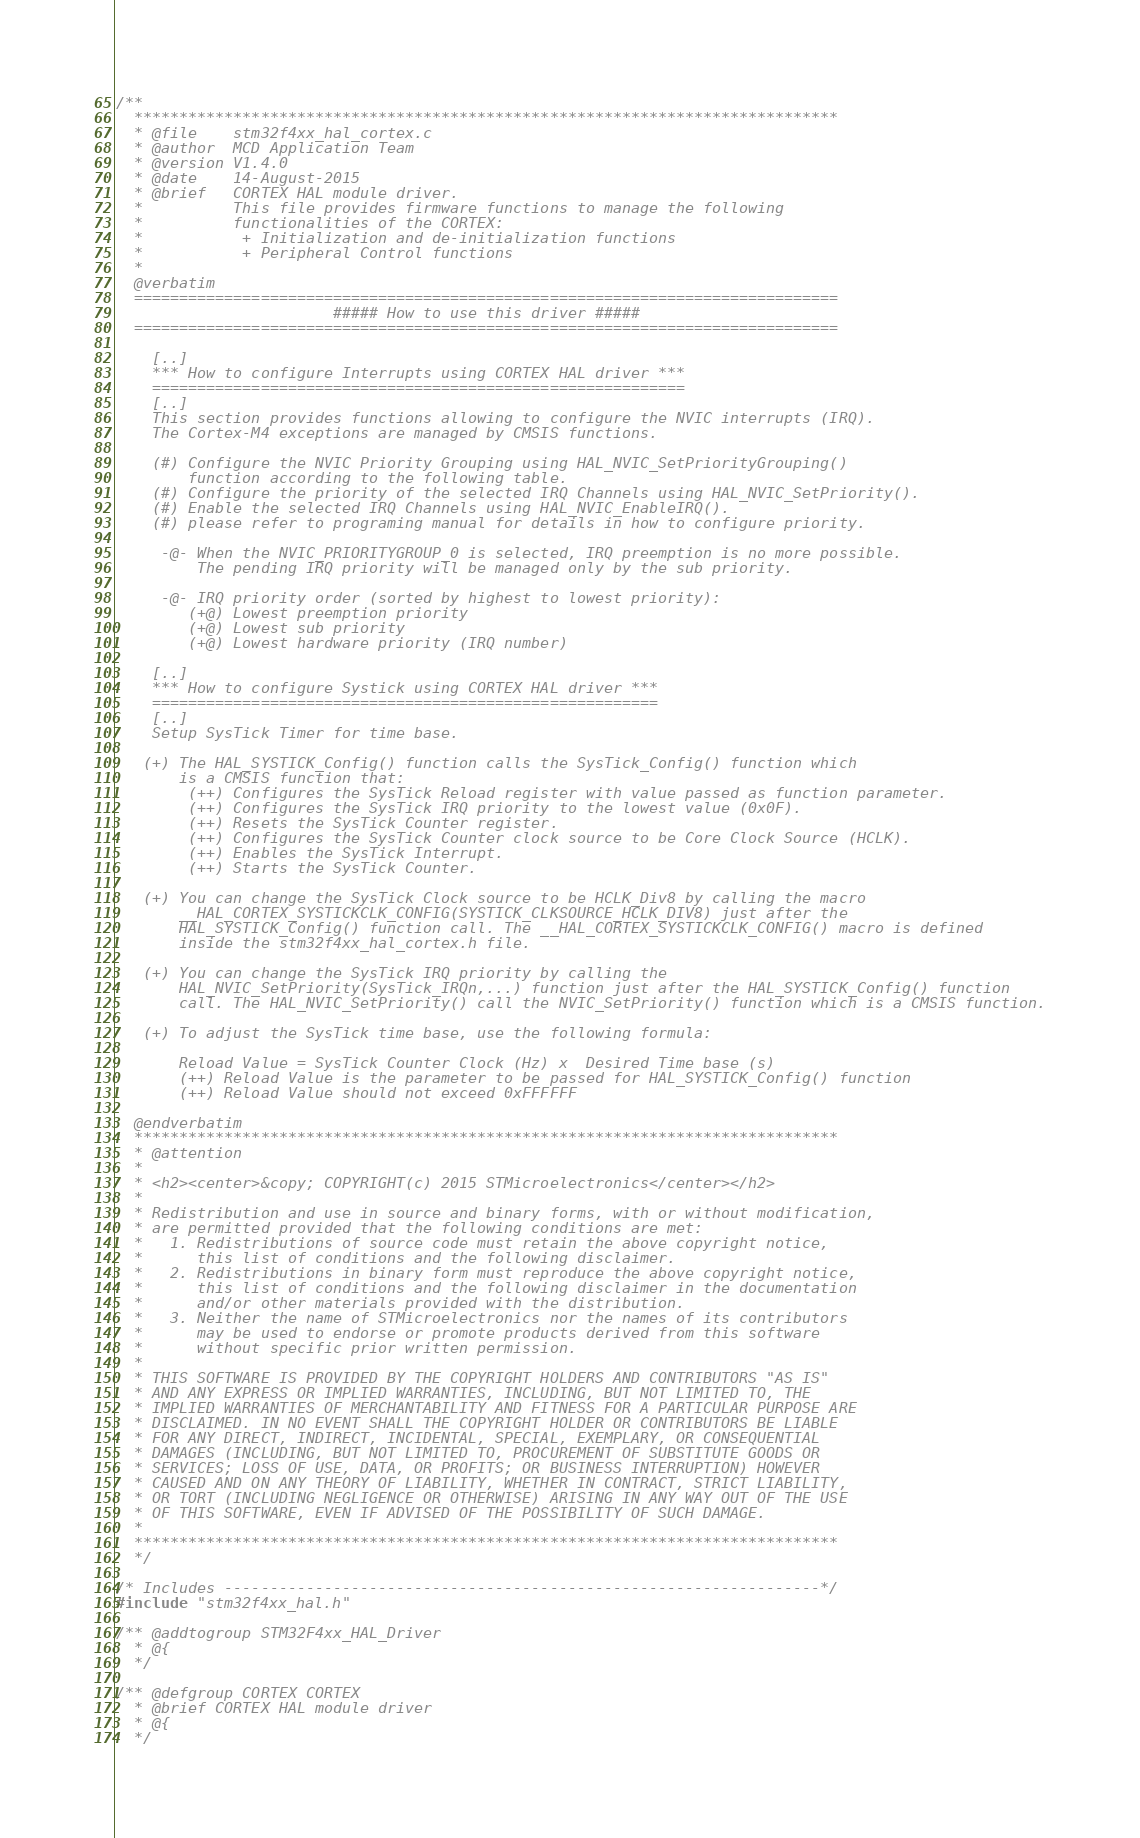<code> <loc_0><loc_0><loc_500><loc_500><_C_>/**
  ******************************************************************************
  * @file    stm32f4xx_hal_cortex.c
  * @author  MCD Application Team
  * @version V1.4.0
  * @date    14-August-2015
  * @brief   CORTEX HAL module driver.
  *          This file provides firmware functions to manage the following 
  *          functionalities of the CORTEX:
  *           + Initialization and de-initialization functions
  *           + Peripheral Control functions 
  *
  @verbatim  
  ==============================================================================
                        ##### How to use this driver #####
  ==============================================================================

    [..]  
    *** How to configure Interrupts using CORTEX HAL driver ***
    ===========================================================
    [..]     
    This section provides functions allowing to configure the NVIC interrupts (IRQ).
    The Cortex-M4 exceptions are managed by CMSIS functions.
   
    (#) Configure the NVIC Priority Grouping using HAL_NVIC_SetPriorityGrouping()
        function according to the following table.
    (#) Configure the priority of the selected IRQ Channels using HAL_NVIC_SetPriority(). 
    (#) Enable the selected IRQ Channels using HAL_NVIC_EnableIRQ().
    (#) please refer to programing manual for details in how to configure priority. 
      
     -@- When the NVIC_PRIORITYGROUP_0 is selected, IRQ preemption is no more possible. 
         The pending IRQ priority will be managed only by the sub priority.
   
     -@- IRQ priority order (sorted by highest to lowest priority):
        (+@) Lowest preemption priority
        (+@) Lowest sub priority
        (+@) Lowest hardware priority (IRQ number)
 
    [..]  
    *** How to configure Systick using CORTEX HAL driver ***
    ========================================================
    [..]
    Setup SysTick Timer for time base.
           
   (+) The HAL_SYSTICK_Config() function calls the SysTick_Config() function which
       is a CMSIS function that:
        (++) Configures the SysTick Reload register with value passed as function parameter.
        (++) Configures the SysTick IRQ priority to the lowest value (0x0F).
        (++) Resets the SysTick Counter register.
        (++) Configures the SysTick Counter clock source to be Core Clock Source (HCLK).
        (++) Enables the SysTick Interrupt.
        (++) Starts the SysTick Counter.
    
   (+) You can change the SysTick Clock source to be HCLK_Div8 by calling the macro
       __HAL_CORTEX_SYSTICKCLK_CONFIG(SYSTICK_CLKSOURCE_HCLK_DIV8) just after the
       HAL_SYSTICK_Config() function call. The __HAL_CORTEX_SYSTICKCLK_CONFIG() macro is defined
       inside the stm32f4xx_hal_cortex.h file.

   (+) You can change the SysTick IRQ priority by calling the
       HAL_NVIC_SetPriority(SysTick_IRQn,...) function just after the HAL_SYSTICK_Config() function 
       call. The HAL_NVIC_SetPriority() call the NVIC_SetPriority() function which is a CMSIS function.

   (+) To adjust the SysTick time base, use the following formula:
                            
       Reload Value = SysTick Counter Clock (Hz) x  Desired Time base (s)
       (++) Reload Value is the parameter to be passed for HAL_SYSTICK_Config() function
       (++) Reload Value should not exceed 0xFFFFFF
   
  @endverbatim
  ******************************************************************************
  * @attention
  *
  * <h2><center>&copy; COPYRIGHT(c) 2015 STMicroelectronics</center></h2>
  *
  * Redistribution and use in source and binary forms, with or without modification,
  * are permitted provided that the following conditions are met:
  *   1. Redistributions of source code must retain the above copyright notice,
  *      this list of conditions and the following disclaimer.
  *   2. Redistributions in binary form must reproduce the above copyright notice,
  *      this list of conditions and the following disclaimer in the documentation
  *      and/or other materials provided with the distribution.
  *   3. Neither the name of STMicroelectronics nor the names of its contributors
  *      may be used to endorse or promote products derived from this software
  *      without specific prior written permission.
  *
  * THIS SOFTWARE IS PROVIDED BY THE COPYRIGHT HOLDERS AND CONTRIBUTORS "AS IS"
  * AND ANY EXPRESS OR IMPLIED WARRANTIES, INCLUDING, BUT NOT LIMITED TO, THE
  * IMPLIED WARRANTIES OF MERCHANTABILITY AND FITNESS FOR A PARTICULAR PURPOSE ARE
  * DISCLAIMED. IN NO EVENT SHALL THE COPYRIGHT HOLDER OR CONTRIBUTORS BE LIABLE
  * FOR ANY DIRECT, INDIRECT, INCIDENTAL, SPECIAL, EXEMPLARY, OR CONSEQUENTIAL
  * DAMAGES (INCLUDING, BUT NOT LIMITED TO, PROCUREMENT OF SUBSTITUTE GOODS OR
  * SERVICES; LOSS OF USE, DATA, OR PROFITS; OR BUSINESS INTERRUPTION) HOWEVER
  * CAUSED AND ON ANY THEORY OF LIABILITY, WHETHER IN CONTRACT, STRICT LIABILITY,
  * OR TORT (INCLUDING NEGLIGENCE OR OTHERWISE) ARISING IN ANY WAY OUT OF THE USE
  * OF THIS SOFTWARE, EVEN IF ADVISED OF THE POSSIBILITY OF SUCH DAMAGE.
  *
  ******************************************************************************
  */

/* Includes ------------------------------------------------------------------*/
#include "stm32f4xx_hal.h"

/** @addtogroup STM32F4xx_HAL_Driver
  * @{
  */

/** @defgroup CORTEX CORTEX
  * @brief CORTEX HAL module driver
  * @{
  */
</code> 